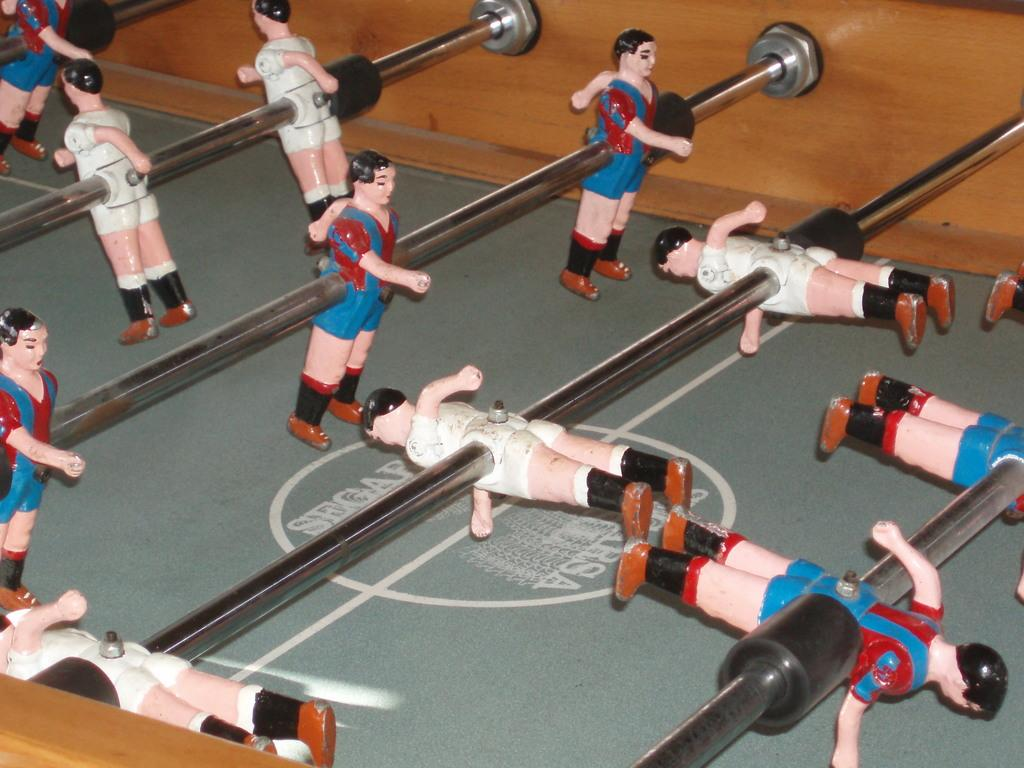What type of game is shown in the image? The image depicts a table football game. What are the main components of the game? There are bars with figures on them in the game. How are the bars connected to the game's structure? The bars are attached to a wooden wall. Is there any branding or identification on the table? Yes, there is a logo on the table. Can you see any branches growing from the table football game in the image? No, there are no branches growing from the table football game in the image. Is there a pan visible on the table in the image? No, there is no pan visible on the table in the image. 